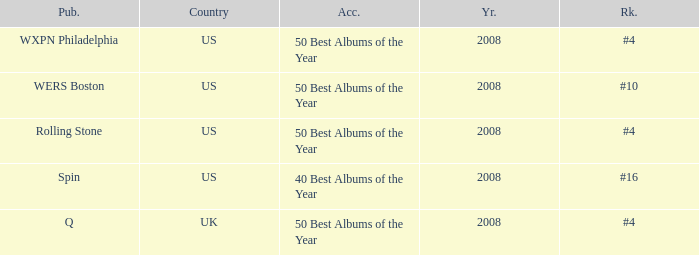Which year's rank was #4 when the country was the US? 2008, 2008. 